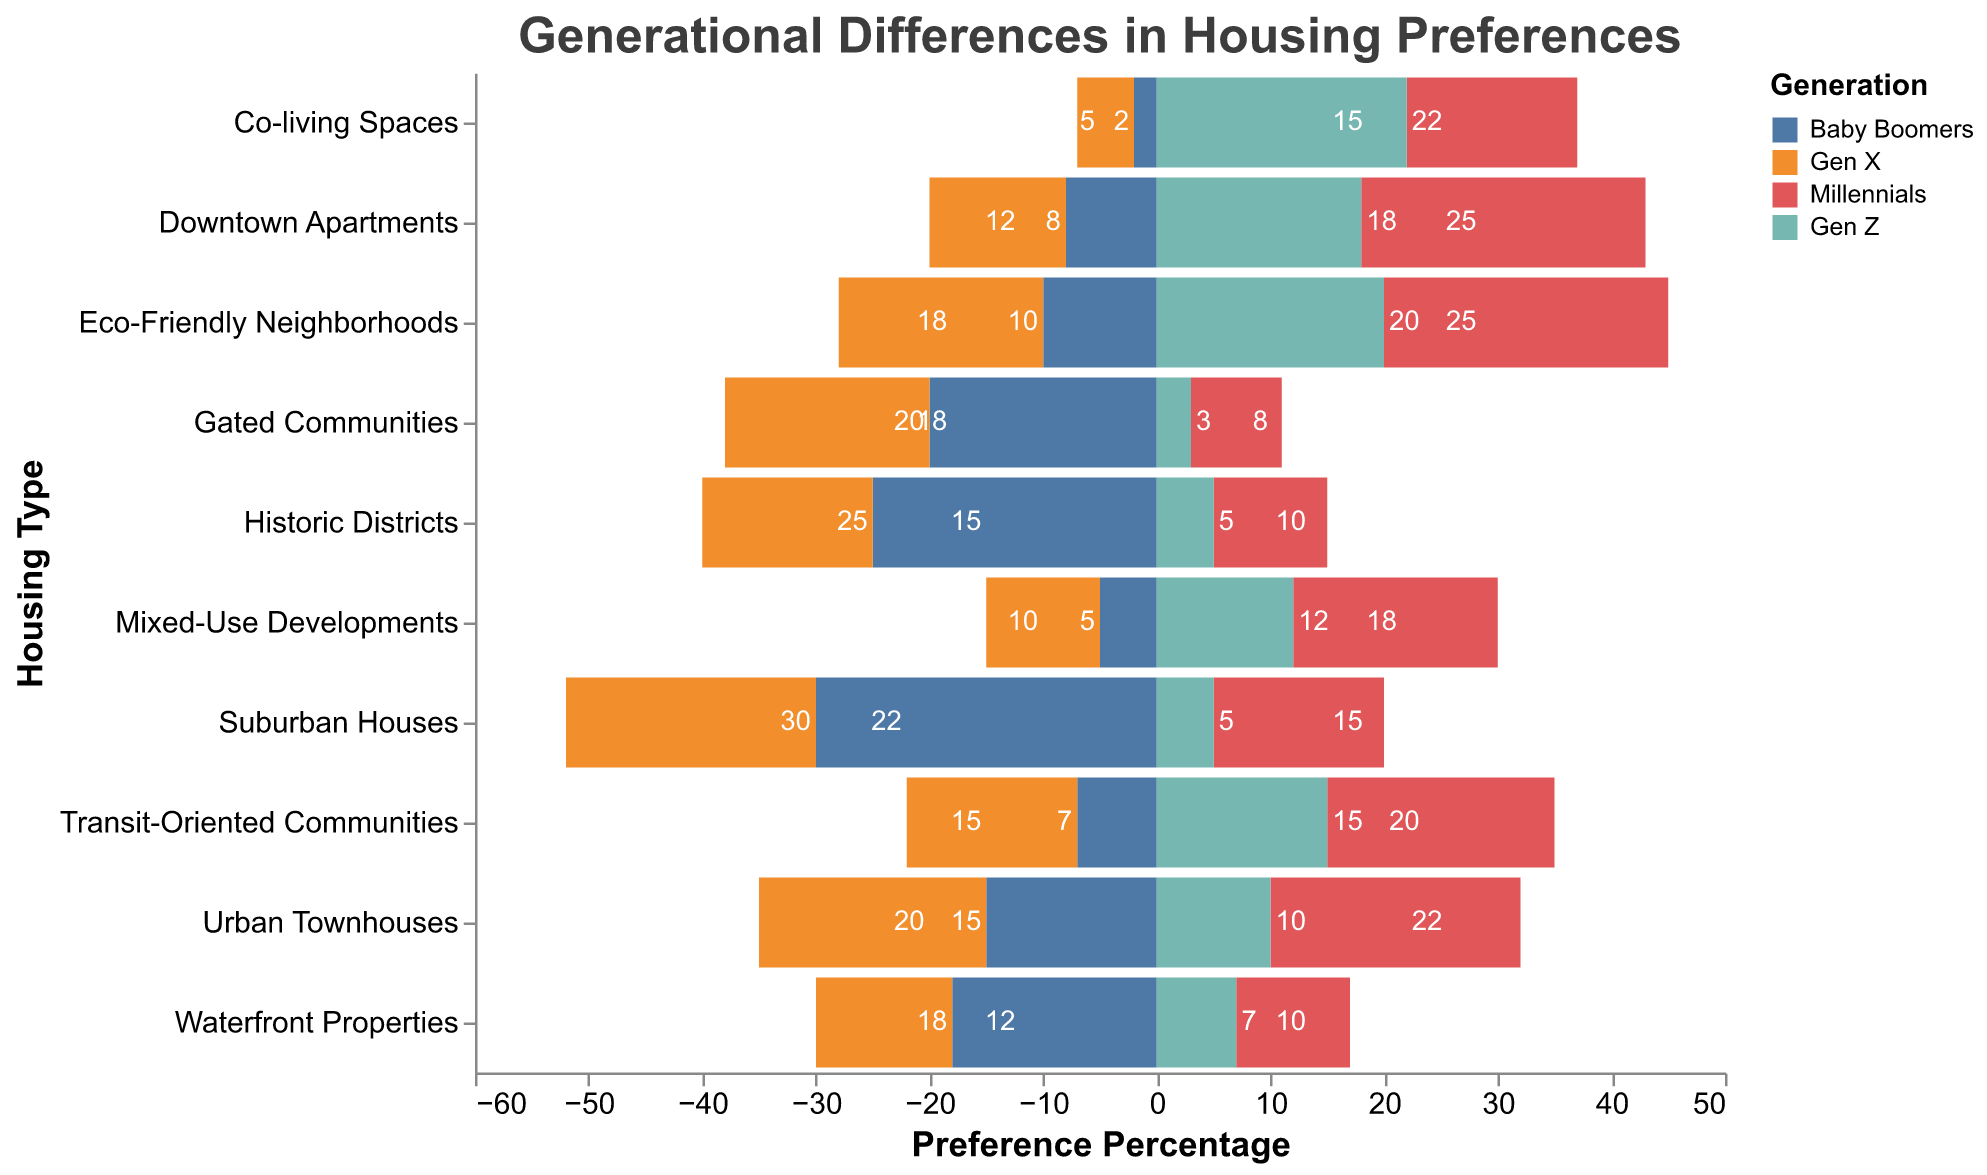What's the title of the chart? The chart's title is displayed at the top and reads "Generational Differences in Housing Preferences."
Answer: Generational Differences in Housing Preferences Which generation shows the highest preference for Downtown Apartments? Looking at the bar lengths for Downtown Apartments, Millennials show the highest preference with a bar length of 25 units.
Answer: Millennials Which housing type do Baby Boomers prefer the most? By looking at the longest bar in Baby Boomers' color, Baby Boomers prefer Suburban Houses with a value of 30 units.
Answer: Suburban Houses What is the combined preference percentage of Gen Z for Transit-Oriented Communities and Eco-Friendly Neighborhoods? The values for Gen Z in Transit-Oriented Communities and Eco-Friendly Neighborhoods are 15 and 20, respectively. Adding them together gives 15 + 20 = 35.
Answer: 35 Do Gen X individuals prefer Urban Townhouses or Waterfront Properties more? Comparing the bar lengths for Gen X, Urban Townhouses have a value of 20, while Waterfront Properties have a value of 12. So, Gen X prefers Urban Townhouses more.
Answer: Urban Townhouses Which generation has the lowest preference for Co-living Spaces, and what is the value? The bar for Baby Boomers in Co-living Spaces is the shortest at 2 units.
Answer: Baby Boomers, 2 What is the total preference percentage for Gated Communities across all generations? Summing the values for Gated Communities: Baby Boomers (20) + Gen X (18) + Millennials (8) + Gen Z (3) = 49.
Answer: 49 How do the preferences of Baby Boomers and Gen X compare for Mixed-Use Developments? The bar lengths for Mixed-Use Developments are 5 for Baby Boomers and 10 for Gen X. Gen X has a higher preference with a difference of 10 - 5 = 5 units.
Answer: Gen X prefers 5 units more Which housing type has the most equal preference between Millennials and Gen Z, and what are the values? Looking for the smallest difference between bars for Millennials and Gen Z: Co-living Spaces have values of 15 and 22, making the difference 7.
Answer: Co-living Spaces, 15 and 22 Among all housing types, in which does Gen Z show the highest preference, and what is the percentage? The longest bar for Gen Z appears in Co-living Spaces with a value of 22 units.
Answer: Co-living Spaces, 22 